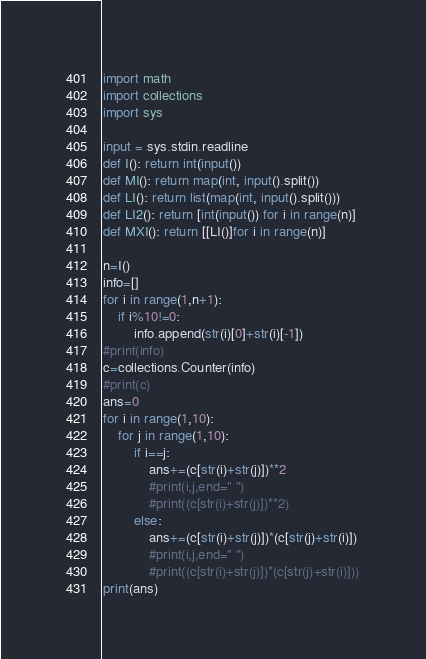Convert code to text. <code><loc_0><loc_0><loc_500><loc_500><_Python_>import math
import collections
import sys

input = sys.stdin.readline
def I(): return int(input())
def MI(): return map(int, input().split())
def LI(): return list(map(int, input().split()))
def LI2(): return [int(input()) for i in range(n)]
def MXI(): return [[LI()]for i in range(n)]

n=I()
info=[]
for i in range(1,n+1):
    if i%10!=0:
        info.append(str(i)[0]+str(i)[-1])
#print(info)
c=collections.Counter(info)
#print(c)
ans=0
for i in range(1,10):
    for j in range(1,10):
        if i==j:
            ans+=(c[str(i)+str(j)])**2
            #print(i,j,end=" ")
            #print((c[str(i)+str(j)])**2)
        else:
            ans+=(c[str(i)+str(j)])*(c[str(j)+str(i)])
            #print(i,j,end=" ")
            #print((c[str(i)+str(j)])*(c[str(j)+str(i)]))
print(ans)</code> 